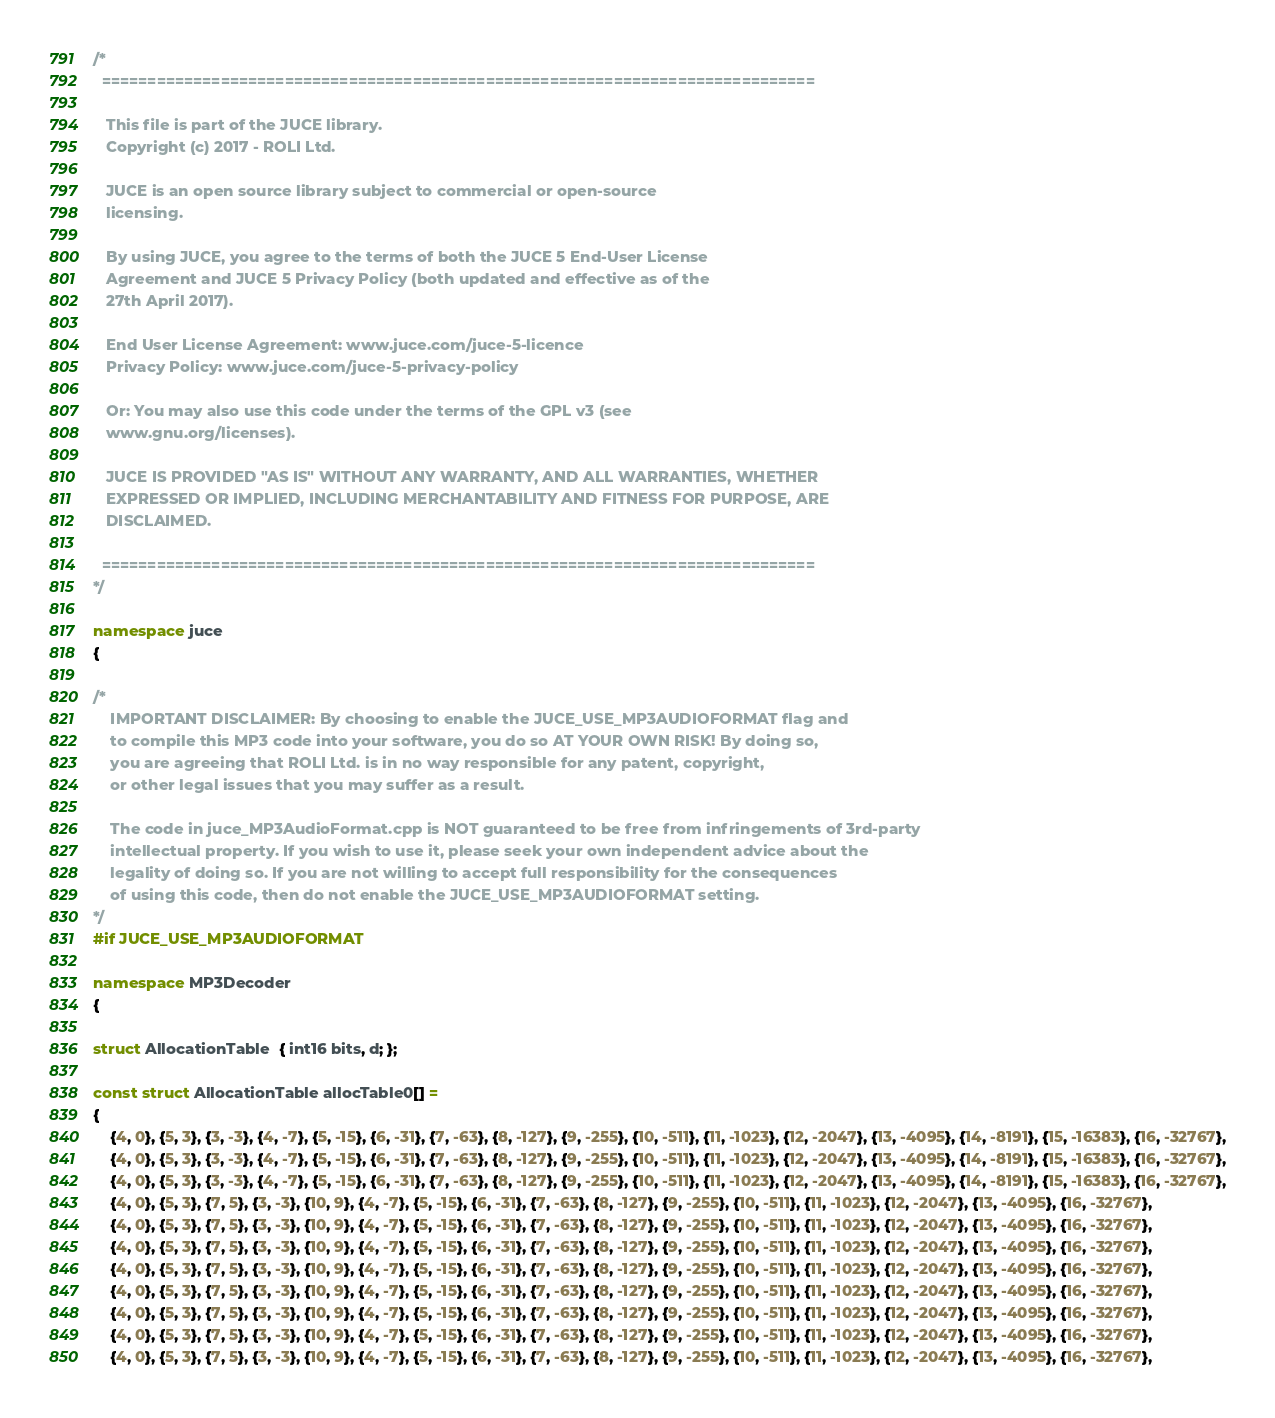<code> <loc_0><loc_0><loc_500><loc_500><_C++_>/*
  ==============================================================================

   This file is part of the JUCE library.
   Copyright (c) 2017 - ROLI Ltd.

   JUCE is an open source library subject to commercial or open-source
   licensing.

   By using JUCE, you agree to the terms of both the JUCE 5 End-User License
   Agreement and JUCE 5 Privacy Policy (both updated and effective as of the
   27th April 2017).

   End User License Agreement: www.juce.com/juce-5-licence
   Privacy Policy: www.juce.com/juce-5-privacy-policy

   Or: You may also use this code under the terms of the GPL v3 (see
   www.gnu.org/licenses).

   JUCE IS PROVIDED "AS IS" WITHOUT ANY WARRANTY, AND ALL WARRANTIES, WHETHER
   EXPRESSED OR IMPLIED, INCLUDING MERCHANTABILITY AND FITNESS FOR PURPOSE, ARE
   DISCLAIMED.

  ==============================================================================
*/

namespace juce
{

/*
    IMPORTANT DISCLAIMER: By choosing to enable the JUCE_USE_MP3AUDIOFORMAT flag and
    to compile this MP3 code into your software, you do so AT YOUR OWN RISK! By doing so,
    you are agreeing that ROLI Ltd. is in no way responsible for any patent, copyright,
    or other legal issues that you may suffer as a result.

    The code in juce_MP3AudioFormat.cpp is NOT guaranteed to be free from infringements of 3rd-party
    intellectual property. If you wish to use it, please seek your own independent advice about the
    legality of doing so. If you are not willing to accept full responsibility for the consequences
    of using this code, then do not enable the JUCE_USE_MP3AUDIOFORMAT setting.
*/
#if JUCE_USE_MP3AUDIOFORMAT

namespace MP3Decoder
{

struct AllocationTable  { int16 bits, d; };

const struct AllocationTable allocTable0[] =
{
    {4, 0}, {5, 3}, {3, -3}, {4, -7}, {5, -15}, {6, -31}, {7, -63}, {8, -127}, {9, -255}, {10, -511}, {11, -1023}, {12, -2047}, {13, -4095}, {14, -8191}, {15, -16383}, {16, -32767},
    {4, 0}, {5, 3}, {3, -3}, {4, -7}, {5, -15}, {6, -31}, {7, -63}, {8, -127}, {9, -255}, {10, -511}, {11, -1023}, {12, -2047}, {13, -4095}, {14, -8191}, {15, -16383}, {16, -32767},
    {4, 0}, {5, 3}, {3, -3}, {4, -7}, {5, -15}, {6, -31}, {7, -63}, {8, -127}, {9, -255}, {10, -511}, {11, -1023}, {12, -2047}, {13, -4095}, {14, -8191}, {15, -16383}, {16, -32767},
    {4, 0}, {5, 3}, {7, 5}, {3, -3}, {10, 9}, {4, -7}, {5, -15}, {6, -31}, {7, -63}, {8, -127}, {9, -255}, {10, -511}, {11, -1023}, {12, -2047}, {13, -4095}, {16, -32767},
    {4, 0}, {5, 3}, {7, 5}, {3, -3}, {10, 9}, {4, -7}, {5, -15}, {6, -31}, {7, -63}, {8, -127}, {9, -255}, {10, -511}, {11, -1023}, {12, -2047}, {13, -4095}, {16, -32767},
    {4, 0}, {5, 3}, {7, 5}, {3, -3}, {10, 9}, {4, -7}, {5, -15}, {6, -31}, {7, -63}, {8, -127}, {9, -255}, {10, -511}, {11, -1023}, {12, -2047}, {13, -4095}, {16, -32767},
    {4, 0}, {5, 3}, {7, 5}, {3, -3}, {10, 9}, {4, -7}, {5, -15}, {6, -31}, {7, -63}, {8, -127}, {9, -255}, {10, -511}, {11, -1023}, {12, -2047}, {13, -4095}, {16, -32767},
    {4, 0}, {5, 3}, {7, 5}, {3, -3}, {10, 9}, {4, -7}, {5, -15}, {6, -31}, {7, -63}, {8, -127}, {9, -255}, {10, -511}, {11, -1023}, {12, -2047}, {13, -4095}, {16, -32767},
    {4, 0}, {5, 3}, {7, 5}, {3, -3}, {10, 9}, {4, -7}, {5, -15}, {6, -31}, {7, -63}, {8, -127}, {9, -255}, {10, -511}, {11, -1023}, {12, -2047}, {13, -4095}, {16, -32767},
    {4, 0}, {5, 3}, {7, 5}, {3, -3}, {10, 9}, {4, -7}, {5, -15}, {6, -31}, {7, -63}, {8, -127}, {9, -255}, {10, -511}, {11, -1023}, {12, -2047}, {13, -4095}, {16, -32767},
    {4, 0}, {5, 3}, {7, 5}, {3, -3}, {10, 9}, {4, -7}, {5, -15}, {6, -31}, {7, -63}, {8, -127}, {9, -255}, {10, -511}, {11, -1023}, {12, -2047}, {13, -4095}, {16, -32767},</code> 